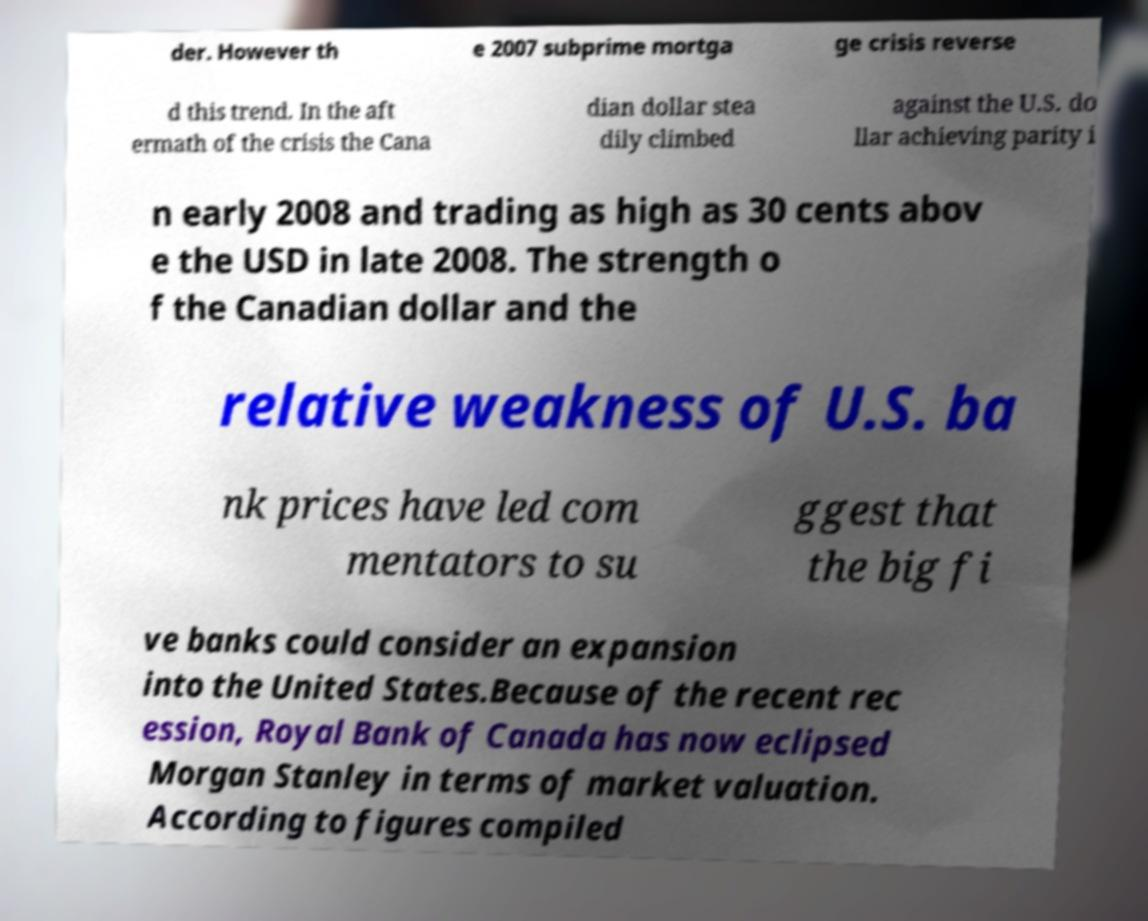Can you accurately transcribe the text from the provided image for me? der. However th e 2007 subprime mortga ge crisis reverse d this trend. In the aft ermath of the crisis the Cana dian dollar stea dily climbed against the U.S. do llar achieving parity i n early 2008 and trading as high as 30 cents abov e the USD in late 2008. The strength o f the Canadian dollar and the relative weakness of U.S. ba nk prices have led com mentators to su ggest that the big fi ve banks could consider an expansion into the United States.Because of the recent rec ession, Royal Bank of Canada has now eclipsed Morgan Stanley in terms of market valuation. According to figures compiled 